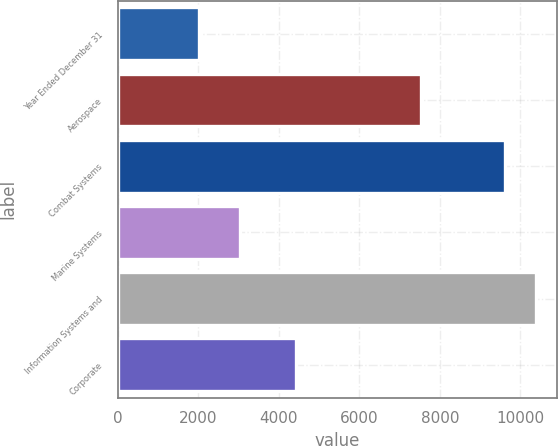Convert chart. <chart><loc_0><loc_0><loc_500><loc_500><bar_chart><fcel>Year Ended December 31<fcel>Aerospace<fcel>Combat Systems<fcel>Marine Systems<fcel>Information Systems and<fcel>Corporate<nl><fcel>2012<fcel>7524<fcel>9619<fcel>3032<fcel>10387.9<fcel>4433<nl></chart> 